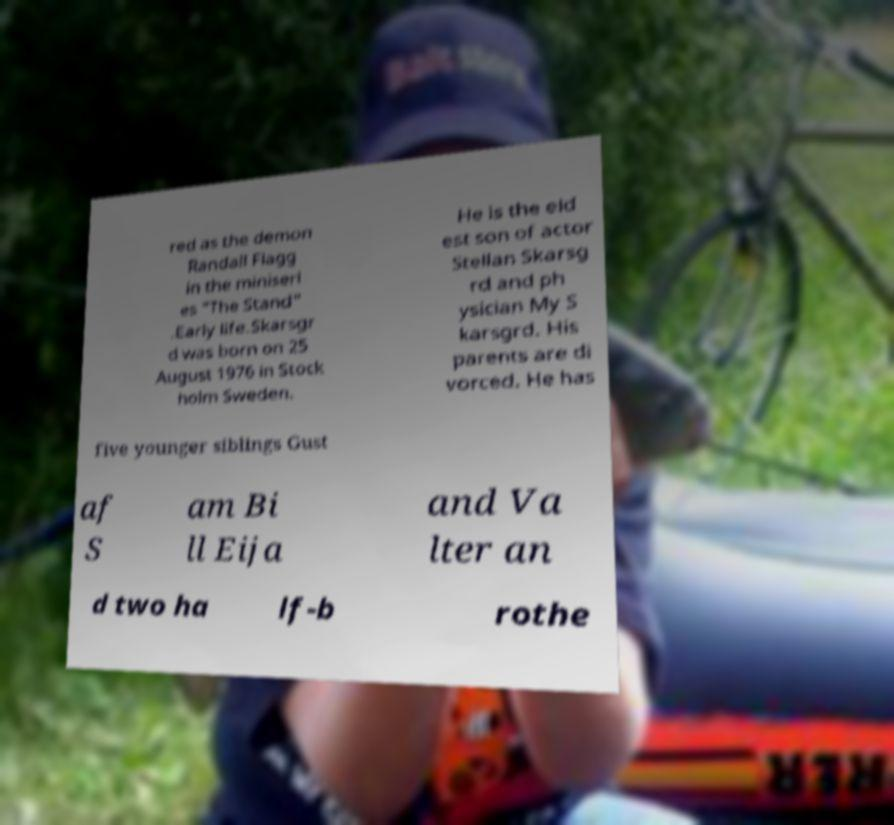Can you read and provide the text displayed in the image?This photo seems to have some interesting text. Can you extract and type it out for me? red as the demon Randall Flagg in the miniseri es "The Stand" .Early life.Skarsgr d was born on 25 August 1976 in Stock holm Sweden. He is the eld est son of actor Stellan Skarsg rd and ph ysician My S karsgrd. His parents are di vorced. He has five younger siblings Gust af S am Bi ll Eija and Va lter an d two ha lf-b rothe 